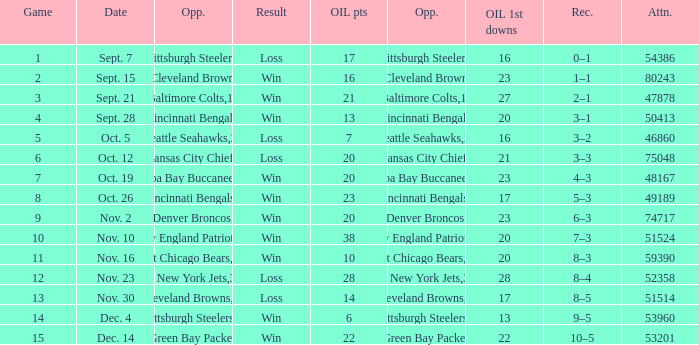What was the total opponents points for the game were the Oilers scored 21? 16.0. 